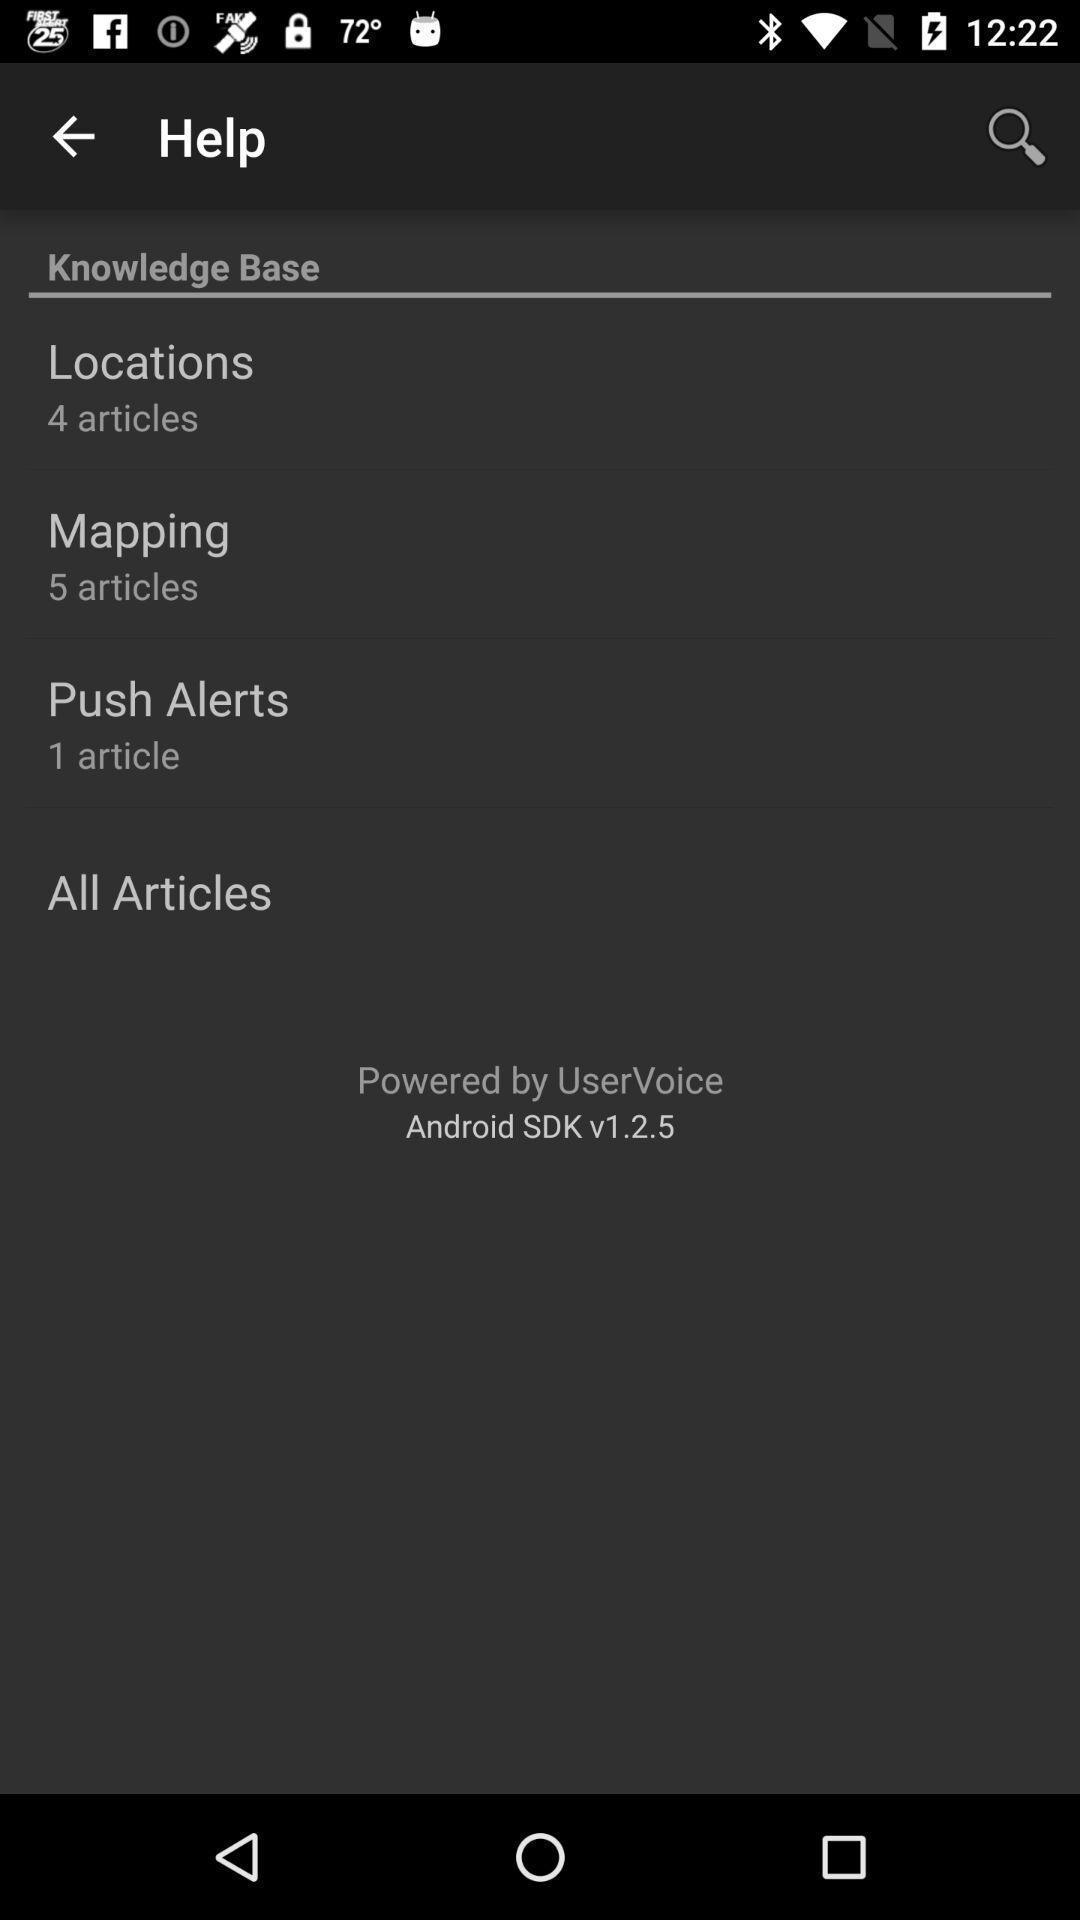Summarize the main components in this picture. Page displaying the search bar results options. 